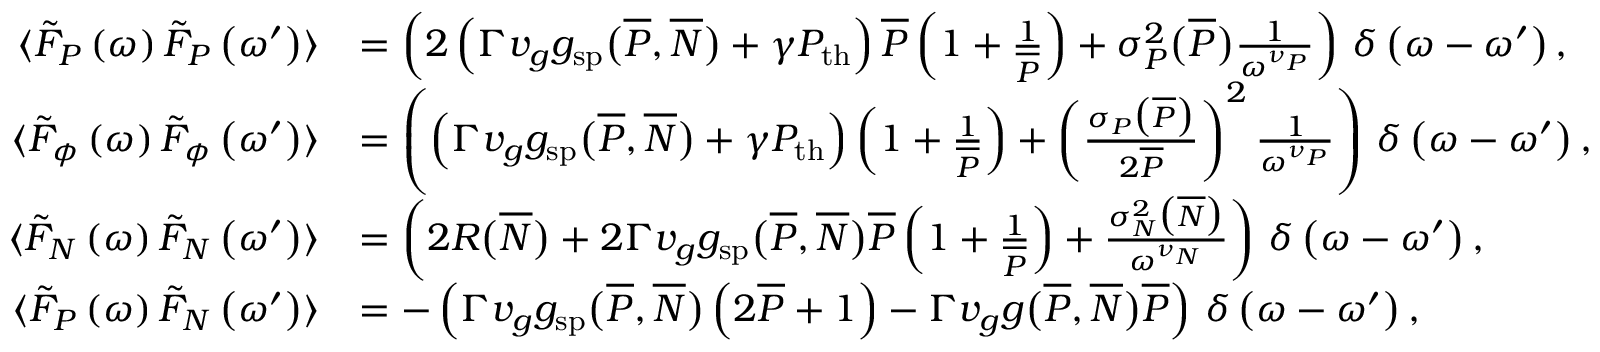<formula> <loc_0><loc_0><loc_500><loc_500>\begin{array} { r } { \begin{array} { r l } { \langle \tilde { F } _ { P } \left ( \omega \right ) \tilde { F } _ { P } \left ( \omega ^ { \prime } \right ) \rangle } & { = \left ( 2 \left ( \Gamma v _ { g } g _ { s p } \left ( \overline { P } , \overline { N } \right ) + \gamma P _ { t h } \right ) \overline { P } \left ( 1 + \frac { 1 } { \overline { P } } \right ) + \sigma _ { P } ^ { 2 } \left ( \overline { P } \right ) \frac { 1 } { \omega ^ { \nu _ { P } } } \right ) \, \delta \left ( \omega - \omega ^ { \prime } \right ) , } \\ { \langle \tilde { F } _ { \phi } \left ( \omega \right ) \tilde { F } _ { \phi } \left ( \omega ^ { \prime } \right ) \rangle } & { = \left ( \left ( \Gamma v _ { g } g _ { s p } \left ( \overline { P } , \overline { N } \right ) + \gamma P _ { t h } \right ) \left ( 1 + \frac { 1 } { \overline { P } } \right ) + \left ( \frac { \sigma _ { P } \left ( \overline { P } \right ) } { 2 \overline { P } } \right ) ^ { 2 } \frac { 1 } { \omega ^ { \nu _ { P } } } \right ) \, \delta \left ( \omega - \omega ^ { \prime } \right ) , } \\ { \langle \tilde { F } _ { N } \left ( \omega \right ) \tilde { F } _ { N } \left ( \omega ^ { \prime } \right ) \rangle } & { = \left ( 2 R \left ( \overline { N } \right ) + 2 \Gamma v _ { g } g _ { s p } \left ( \overline { P } , \overline { N } \right ) \overline { P } \left ( 1 + \frac { 1 } { \overline { P } } \right ) + \frac { \sigma _ { N } ^ { 2 } \left ( \overline { N } \right ) } { \omega ^ { \nu _ { N } } } \right ) \, \delta \left ( \omega - \omega ^ { \prime } \right ) , } \\ { \langle \tilde { F } _ { P } \left ( \omega \right ) \tilde { F } _ { N } \left ( \omega ^ { \prime } \right ) \rangle } & { = - \left ( \Gamma v _ { g } g _ { s p } \left ( \overline { P } , \overline { N } \right ) \left ( 2 \overline { P } + 1 \right ) - \Gamma v _ { g } g \left ( \overline { P } , \overline { N } \right ) \overline { P } \right ) \, \delta \left ( \omega - \omega ^ { \prime } \right ) , } \end{array} } \end{array}</formula> 